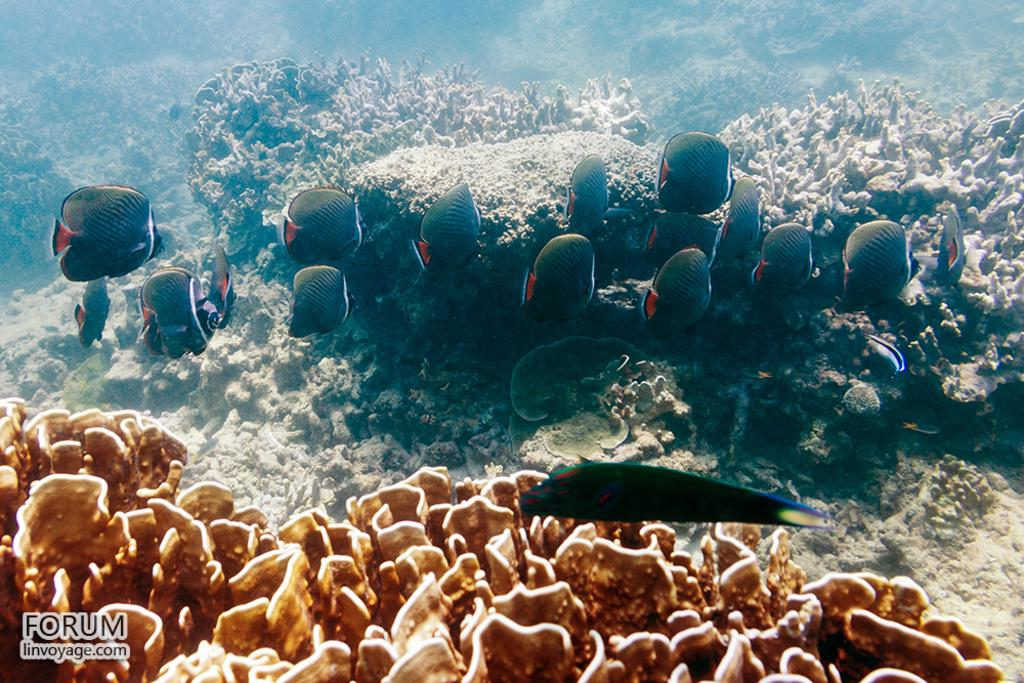Where was the image taken? The image was taken underwater. What can be seen in the foreground of the image? There are coral reefs in the foreground of the image. What is located in the center of the image? In the center of the image, there are fishes, plants, and coral reefs. What type of pets can be seen on the dock in the image? There is no dock or pets present in the image; it was taken underwater and features coral reefs, fishes, and plants. 